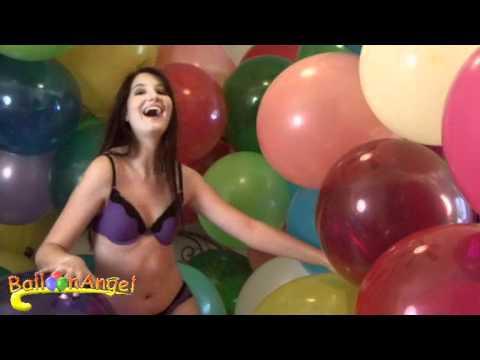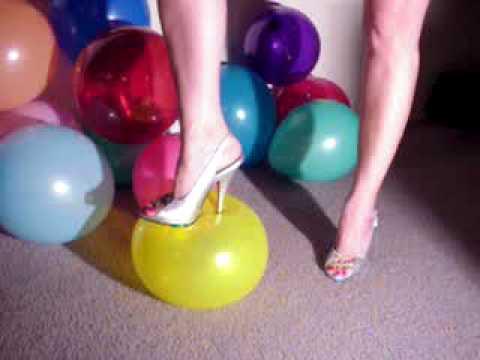The first image is the image on the left, the second image is the image on the right. For the images displayed, is the sentence "Someone is stepping on a blue balloon." factually correct? Answer yes or no. No. The first image is the image on the left, the second image is the image on the right. For the images shown, is this caption "There are two women stepping on balloons." true? Answer yes or no. No. 